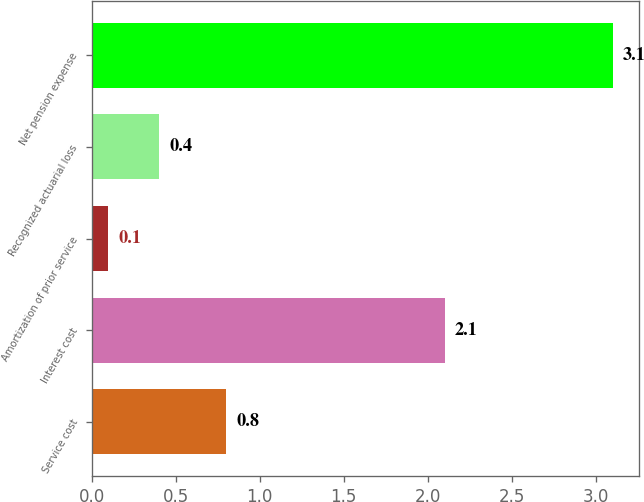<chart> <loc_0><loc_0><loc_500><loc_500><bar_chart><fcel>Service cost<fcel>Interest cost<fcel>Amortization of prior service<fcel>Recognized actuarial loss<fcel>Net pension expense<nl><fcel>0.8<fcel>2.1<fcel>0.1<fcel>0.4<fcel>3.1<nl></chart> 